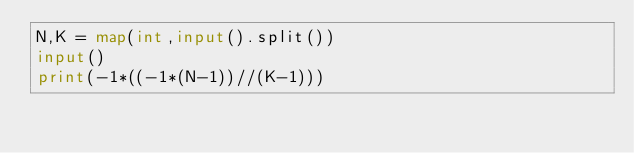<code> <loc_0><loc_0><loc_500><loc_500><_Python_>N,K = map(int,input().split())
input()
print(-1*((-1*(N-1))//(K-1)))</code> 